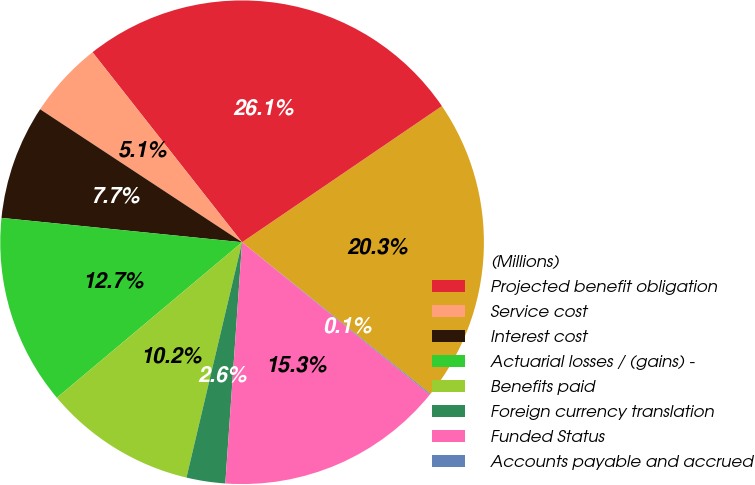<chart> <loc_0><loc_0><loc_500><loc_500><pie_chart><fcel>(Millions)<fcel>Projected benefit obligation<fcel>Service cost<fcel>Interest cost<fcel>Actuarial losses / (gains) -<fcel>Benefits paid<fcel>Foreign currency translation<fcel>Funded Status<fcel>Accounts payable and accrued<nl><fcel>20.31%<fcel>26.09%<fcel>5.12%<fcel>7.66%<fcel>12.72%<fcel>10.19%<fcel>2.59%<fcel>15.25%<fcel>0.06%<nl></chart> 